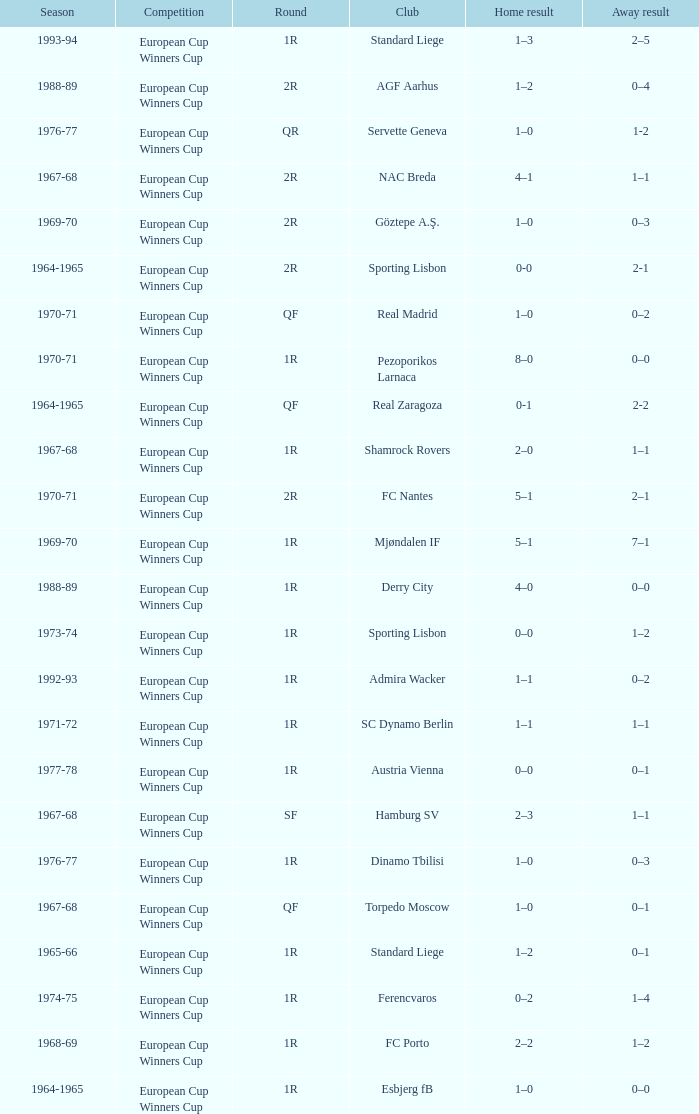Away result of 0–3, and a Season of 1969-70 is what competition? European Cup Winners Cup. 